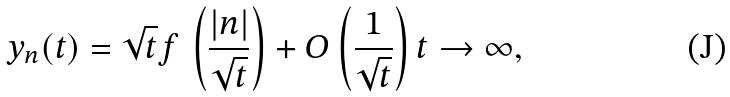Convert formula to latex. <formula><loc_0><loc_0><loc_500><loc_500>y _ { n } ( t ) = \sqrt { t } f \, \left ( \frac { | n | } { \sqrt { t } } \right ) + O \left ( \frac { 1 } { \sqrt { t } } \right ) t \to \infty ,</formula> 